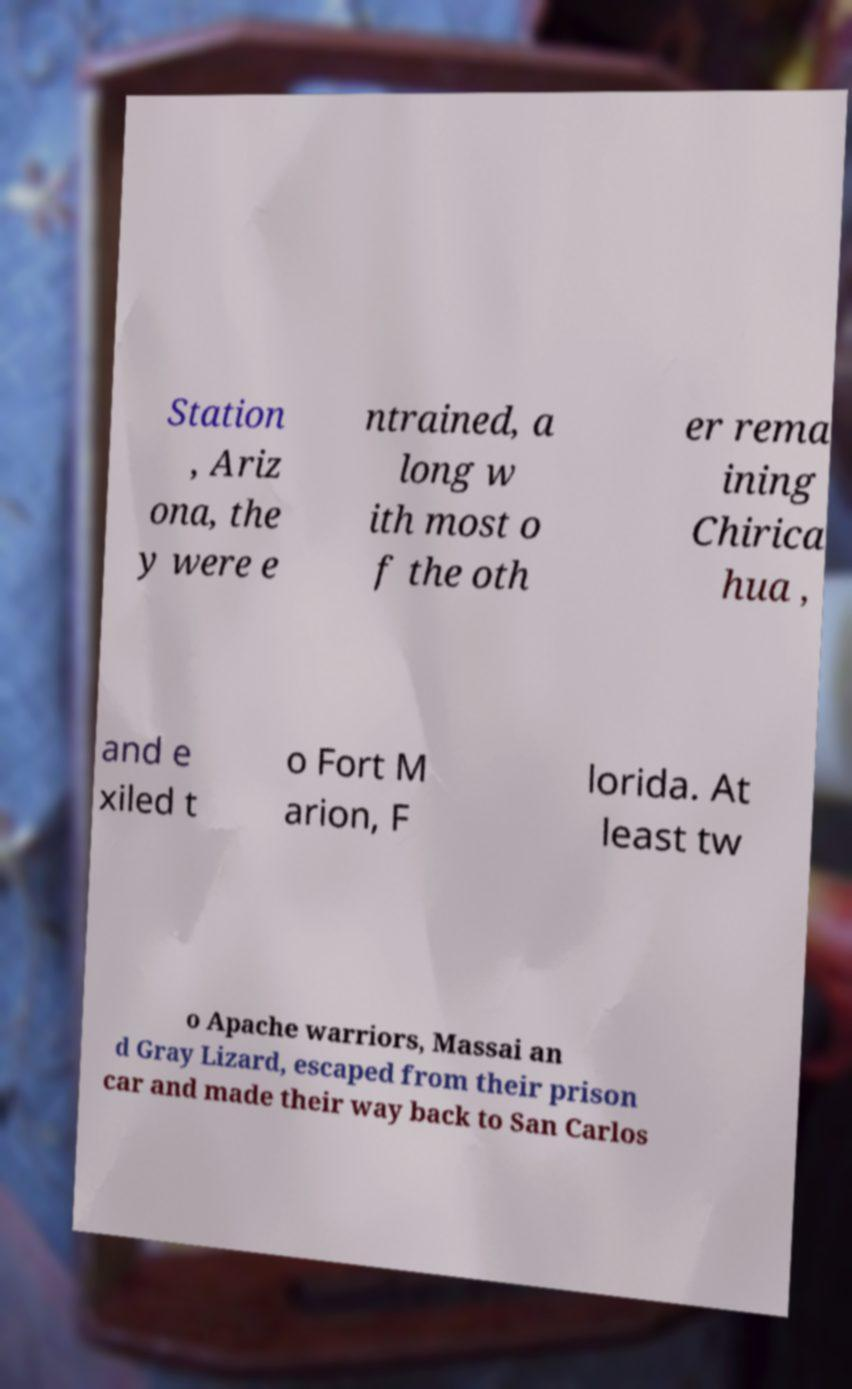Can you read and provide the text displayed in the image?This photo seems to have some interesting text. Can you extract and type it out for me? Station , Ariz ona, the y were e ntrained, a long w ith most o f the oth er rema ining Chirica hua , and e xiled t o Fort M arion, F lorida. At least tw o Apache warriors, Massai an d Gray Lizard, escaped from their prison car and made their way back to San Carlos 